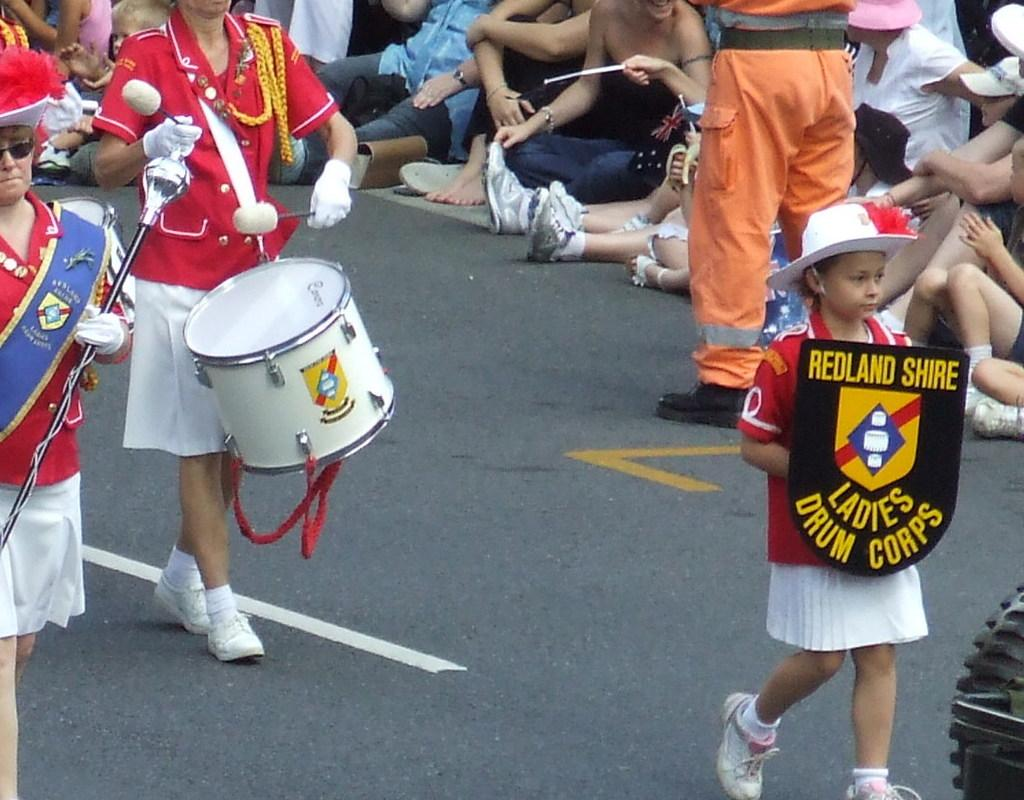<image>
Write a terse but informative summary of the picture. the word Redland that is on a shield 